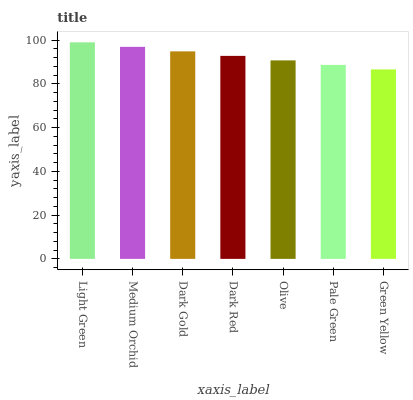Is Green Yellow the minimum?
Answer yes or no. Yes. Is Light Green the maximum?
Answer yes or no. Yes. Is Medium Orchid the minimum?
Answer yes or no. No. Is Medium Orchid the maximum?
Answer yes or no. No. Is Light Green greater than Medium Orchid?
Answer yes or no. Yes. Is Medium Orchid less than Light Green?
Answer yes or no. Yes. Is Medium Orchid greater than Light Green?
Answer yes or no. No. Is Light Green less than Medium Orchid?
Answer yes or no. No. Is Dark Red the high median?
Answer yes or no. Yes. Is Dark Red the low median?
Answer yes or no. Yes. Is Green Yellow the high median?
Answer yes or no. No. Is Green Yellow the low median?
Answer yes or no. No. 